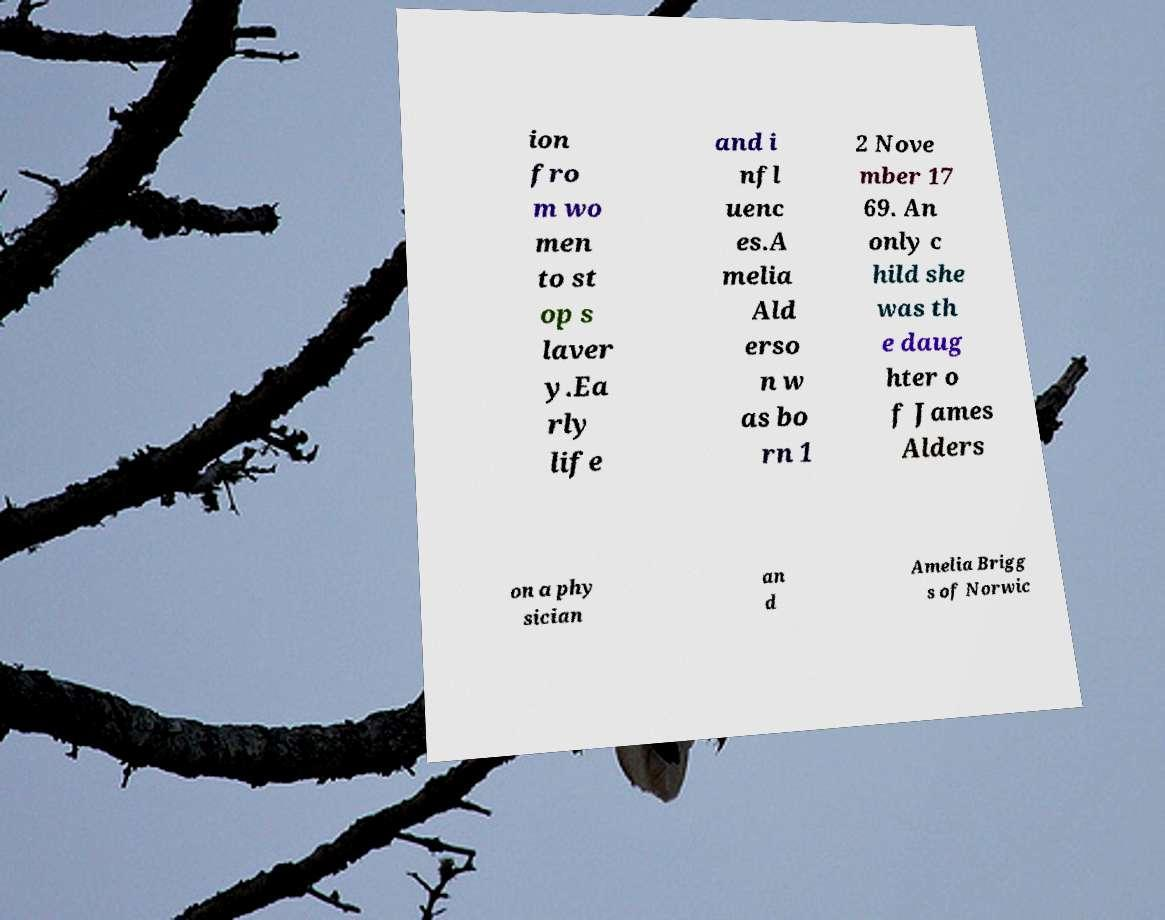Could you assist in decoding the text presented in this image and type it out clearly? ion fro m wo men to st op s laver y.Ea rly life and i nfl uenc es.A melia Ald erso n w as bo rn 1 2 Nove mber 17 69. An only c hild she was th e daug hter o f James Alders on a phy sician an d Amelia Brigg s of Norwic 